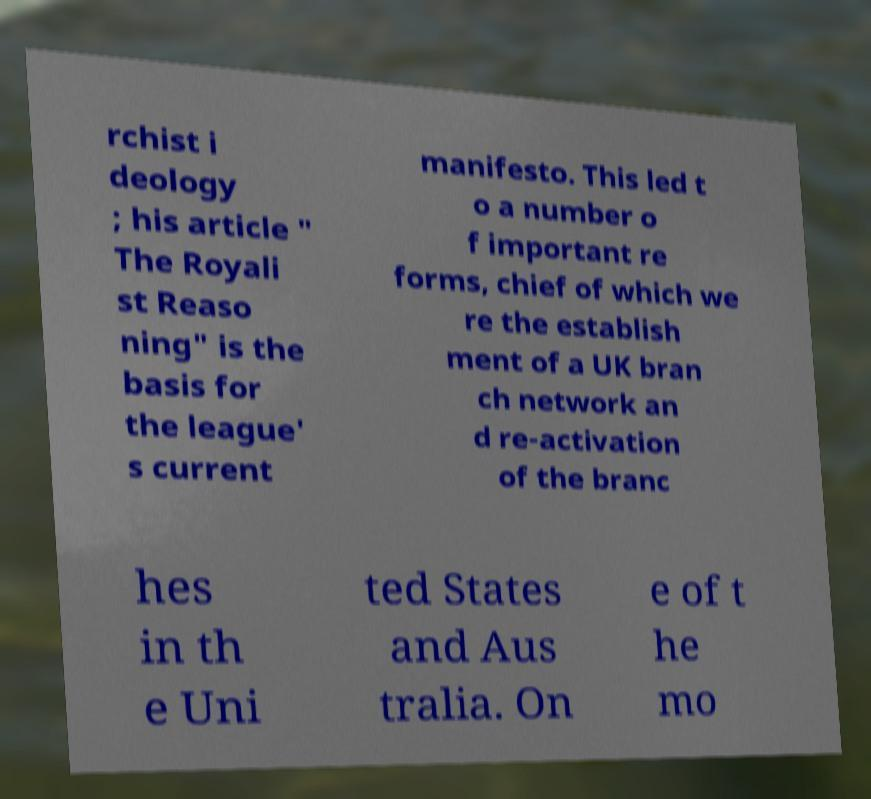Can you read and provide the text displayed in the image?This photo seems to have some interesting text. Can you extract and type it out for me? rchist i deology ; his article " The Royali st Reaso ning" is the basis for the league' s current manifesto. This led t o a number o f important re forms, chief of which we re the establish ment of a UK bran ch network an d re-activation of the branc hes in th e Uni ted States and Aus tralia. On e of t he mo 